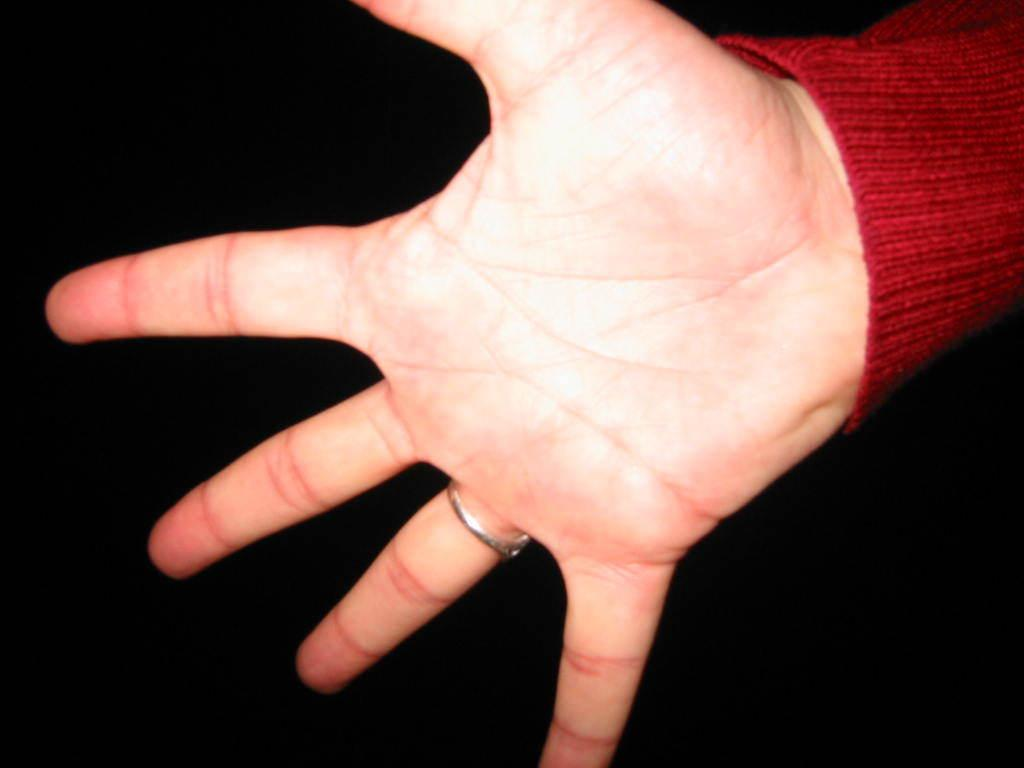What can be seen in the image? There is a hand of a person in the image. What is the color of the background in the image? The background of the image is dark. What type of playground equipment can be seen in the image? There is no playground equipment present in the image; it only features a hand of a person. What is the income of the person whose hand is in the image? The income of the person cannot be determined from the image, as it only shows their hand. 